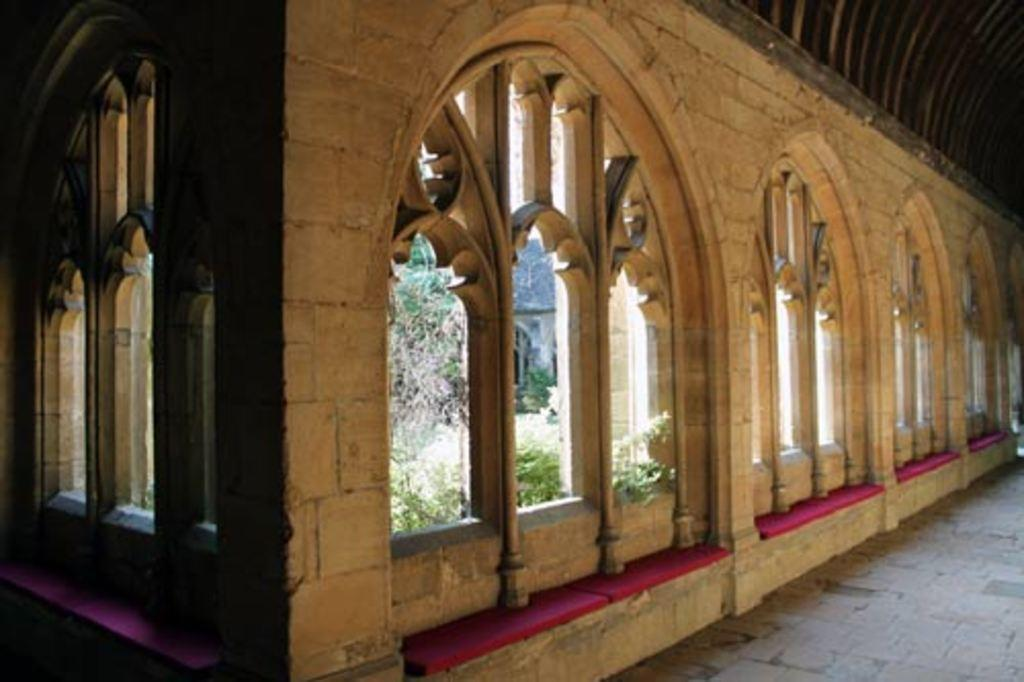What type of structure is visible in the image? There is a wall in the image. What architectural features can be seen on the wall? The wall has arches and pillars. What color is the wall in the image? The wall has a red color. What is the rate of the wall's movement in the image? The wall does not move in the image, so there is no rate of movement to discuss. 